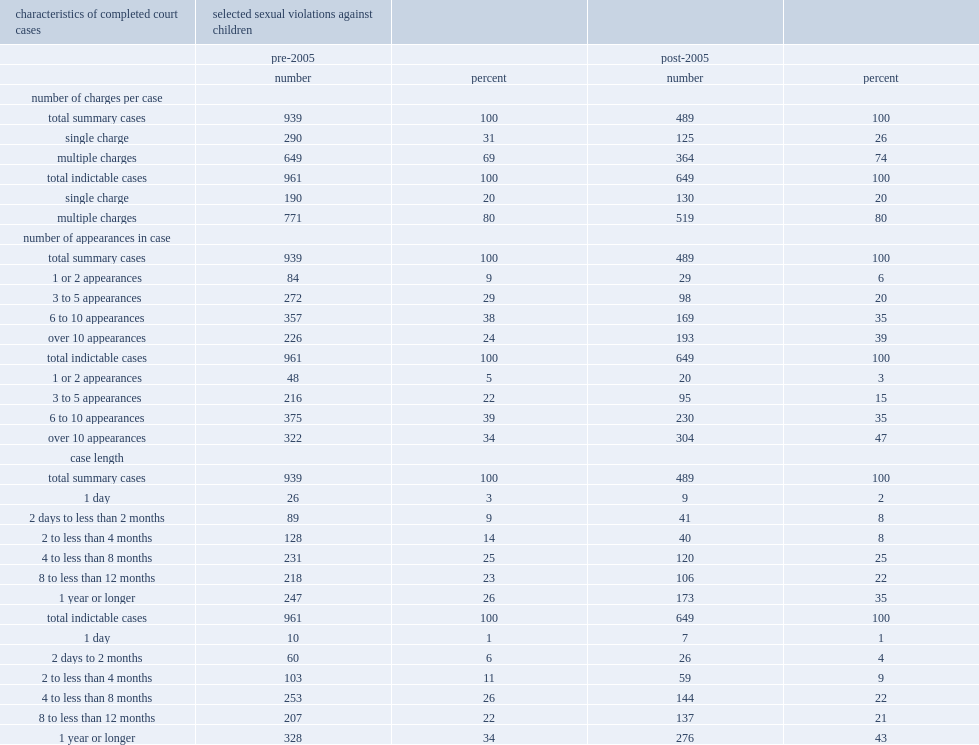What was the percentage of multiple charges that were treated as indictable before 2015? 80.0. What was the percentage of multiple charges that were treated as indictable after 2015? 80.0. 